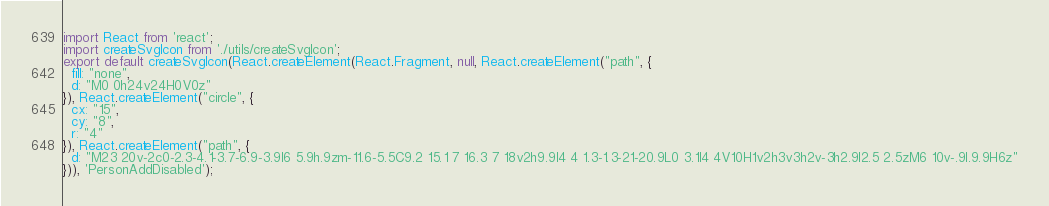<code> <loc_0><loc_0><loc_500><loc_500><_JavaScript_>import React from 'react';
import createSvgIcon from './utils/createSvgIcon';
export default createSvgIcon(React.createElement(React.Fragment, null, React.createElement("path", {
  fill: "none",
  d: "M0 0h24v24H0V0z"
}), React.createElement("circle", {
  cx: "15",
  cy: "8",
  r: "4"
}), React.createElement("path", {
  d: "M23 20v-2c0-2.3-4.1-3.7-6.9-3.9l6 5.9h.9zm-11.6-5.5C9.2 15.1 7 16.3 7 18v2h9.9l4 4 1.3-1.3-21-20.9L0 3.1l4 4V10H1v2h3v3h2v-3h2.9l2.5 2.5zM6 10v-.9l.9.9H6z"
})), 'PersonAddDisabled');</code> 